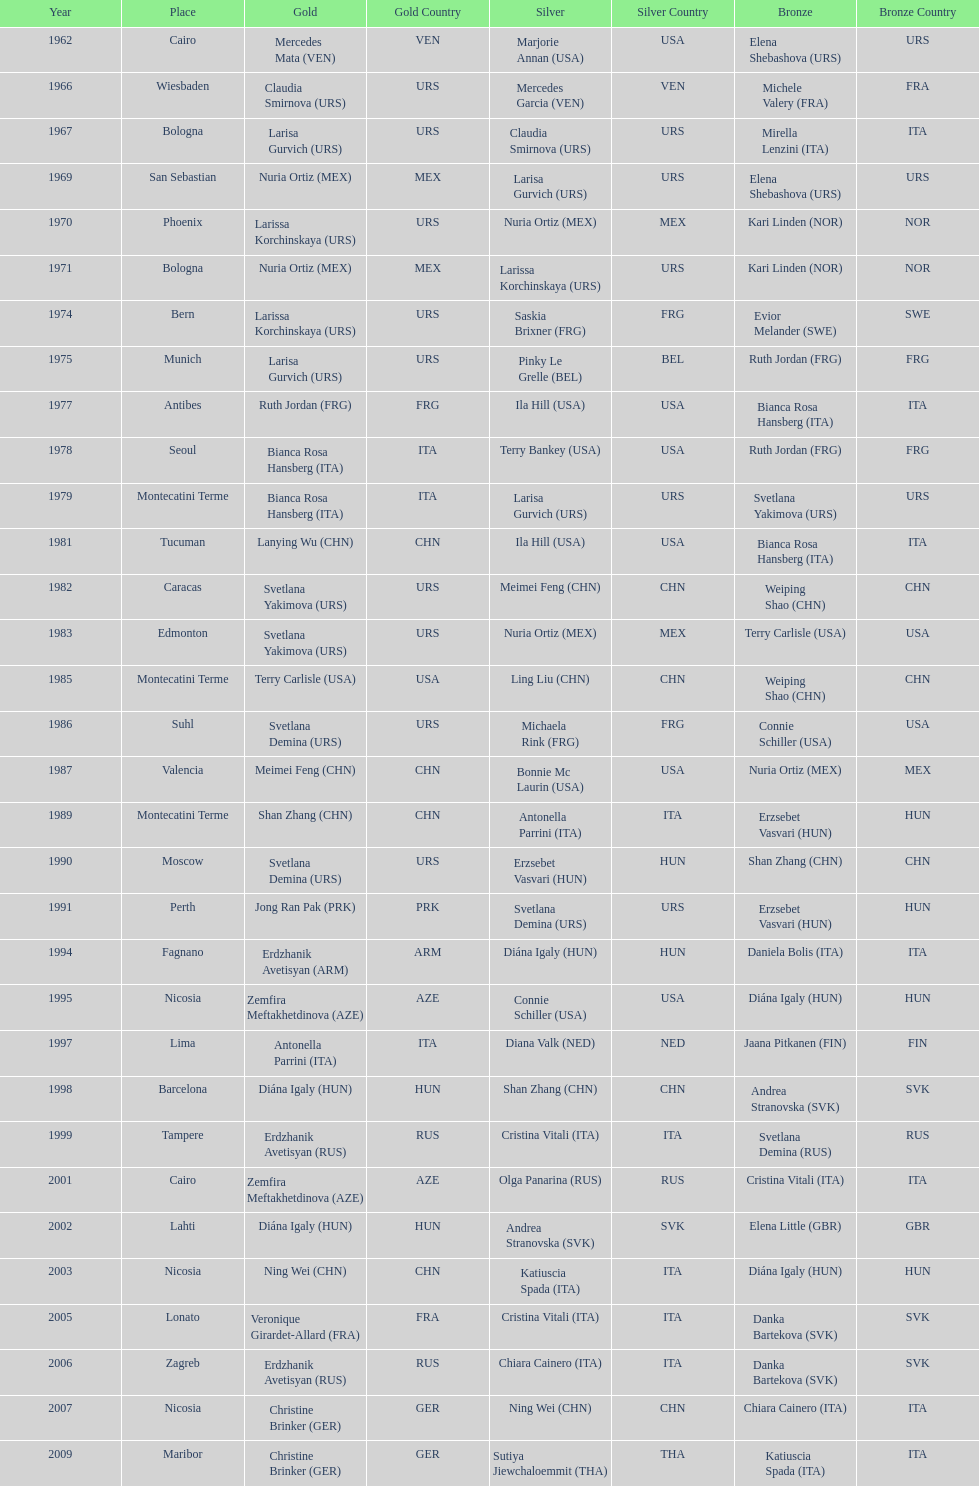Which country has the most bronze medals? Italy. 